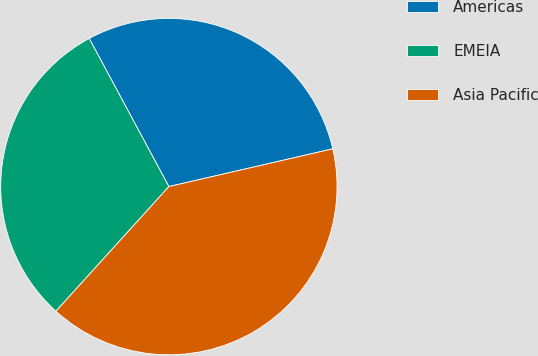<chart> <loc_0><loc_0><loc_500><loc_500><pie_chart><fcel>Americas<fcel>EMEIA<fcel>Asia Pacific<nl><fcel>29.25%<fcel>30.43%<fcel>40.32%<nl></chart> 